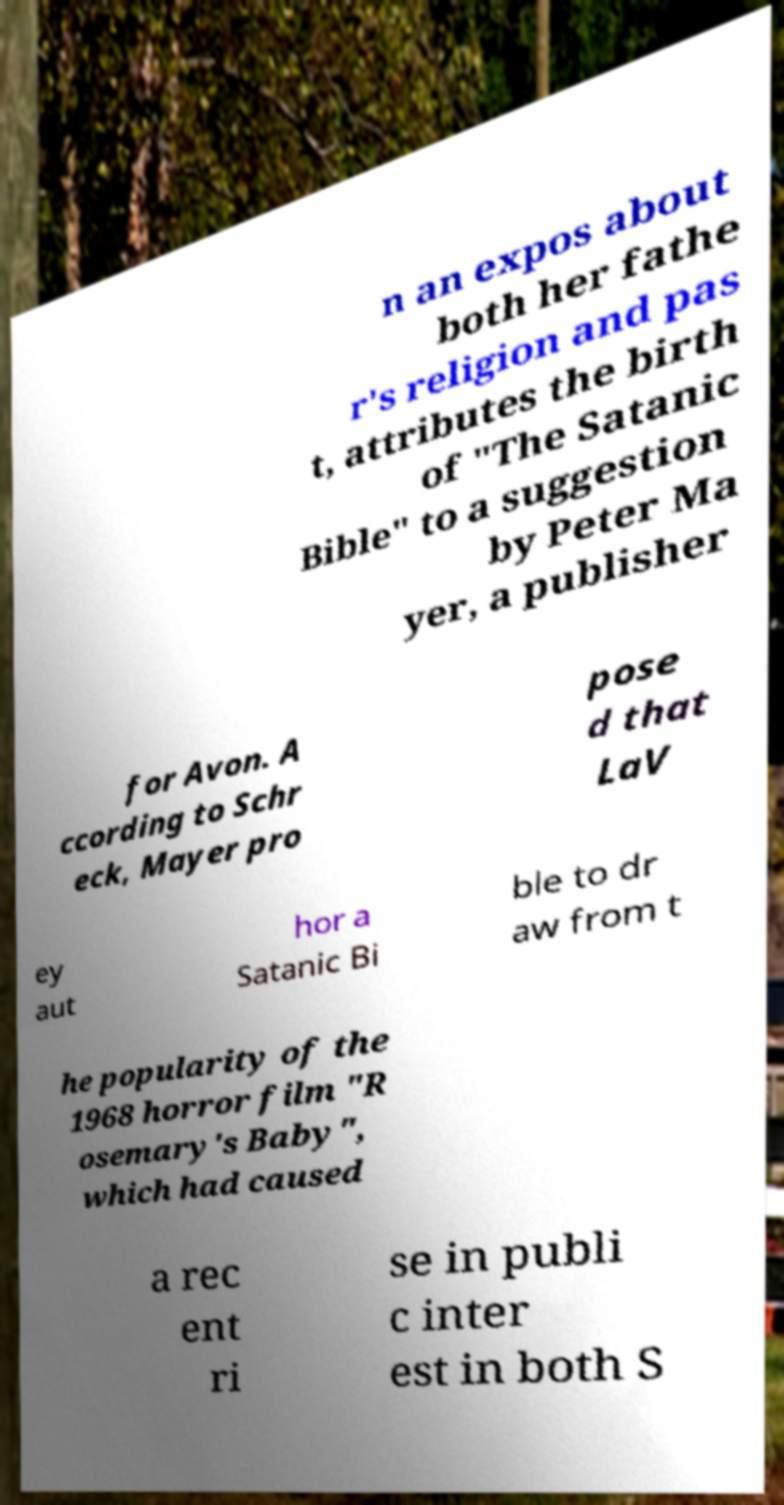Could you extract and type out the text from this image? n an expos about both her fathe r's religion and pas t, attributes the birth of "The Satanic Bible" to a suggestion by Peter Ma yer, a publisher for Avon. A ccording to Schr eck, Mayer pro pose d that LaV ey aut hor a Satanic Bi ble to dr aw from t he popularity of the 1968 horror film "R osemary's Baby", which had caused a rec ent ri se in publi c inter est in both S 